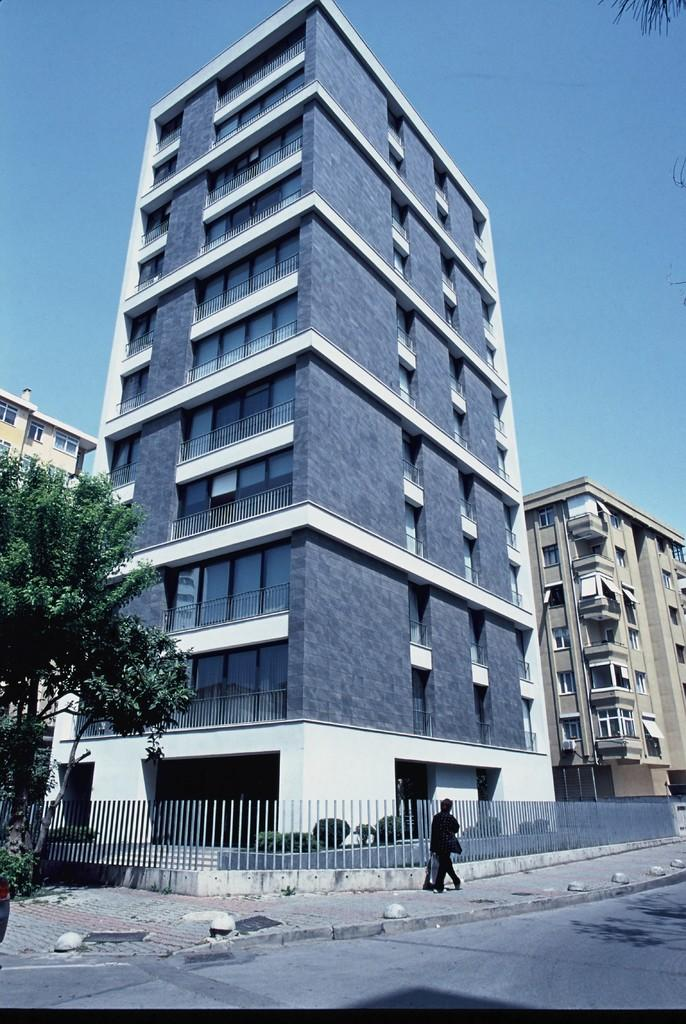What is the main subject of the image? There is a person standing in the center of the image. What can be seen in the foreground of the image? There is a fence in the image. What is visible in the background of the image? There are buildings in the background of the image. What type of vegetation is on the left side of the image? There are trees on the left side of the image. What type of stone is being used to attack the person in the image? There is no stone or attack present in the image; it features a person standing near a fence with trees and buildings in the background. 